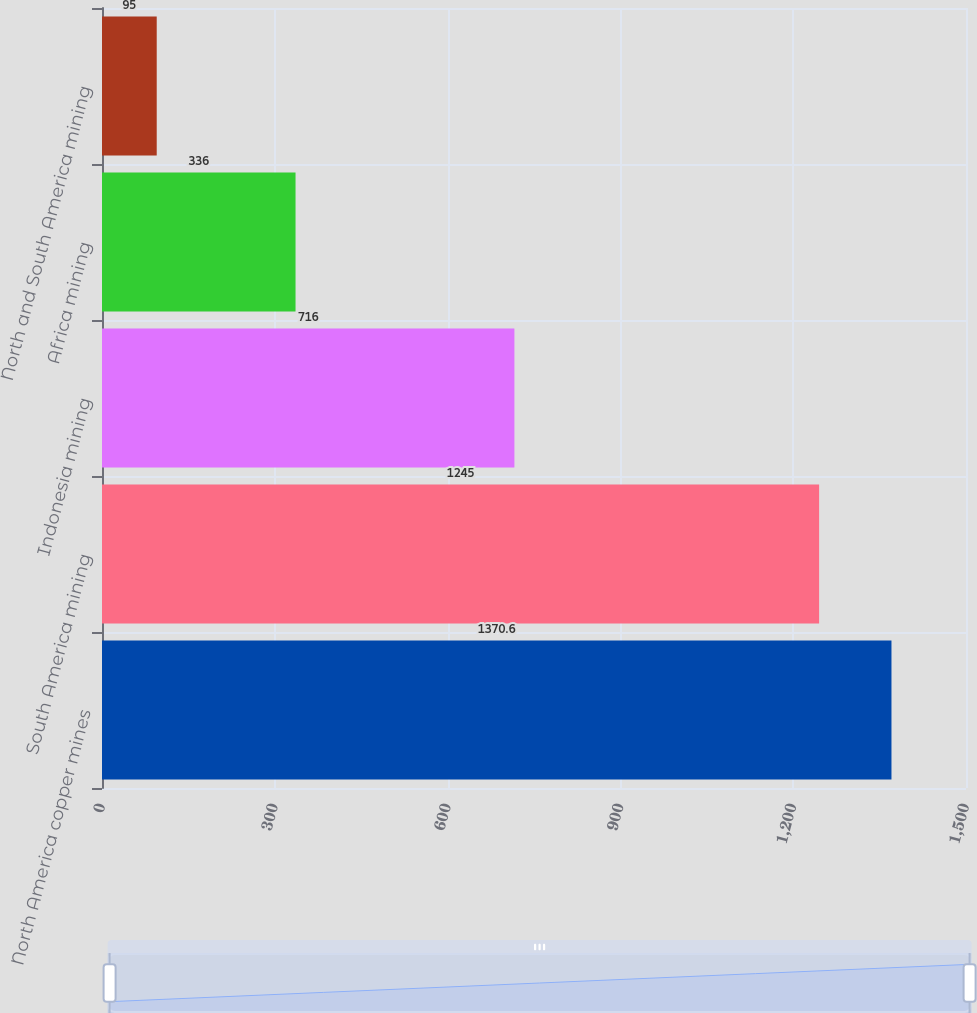<chart> <loc_0><loc_0><loc_500><loc_500><bar_chart><fcel>North America copper mines<fcel>South America mining<fcel>Indonesia mining<fcel>Africa mining<fcel>North and South America mining<nl><fcel>1370.6<fcel>1245<fcel>716<fcel>336<fcel>95<nl></chart> 